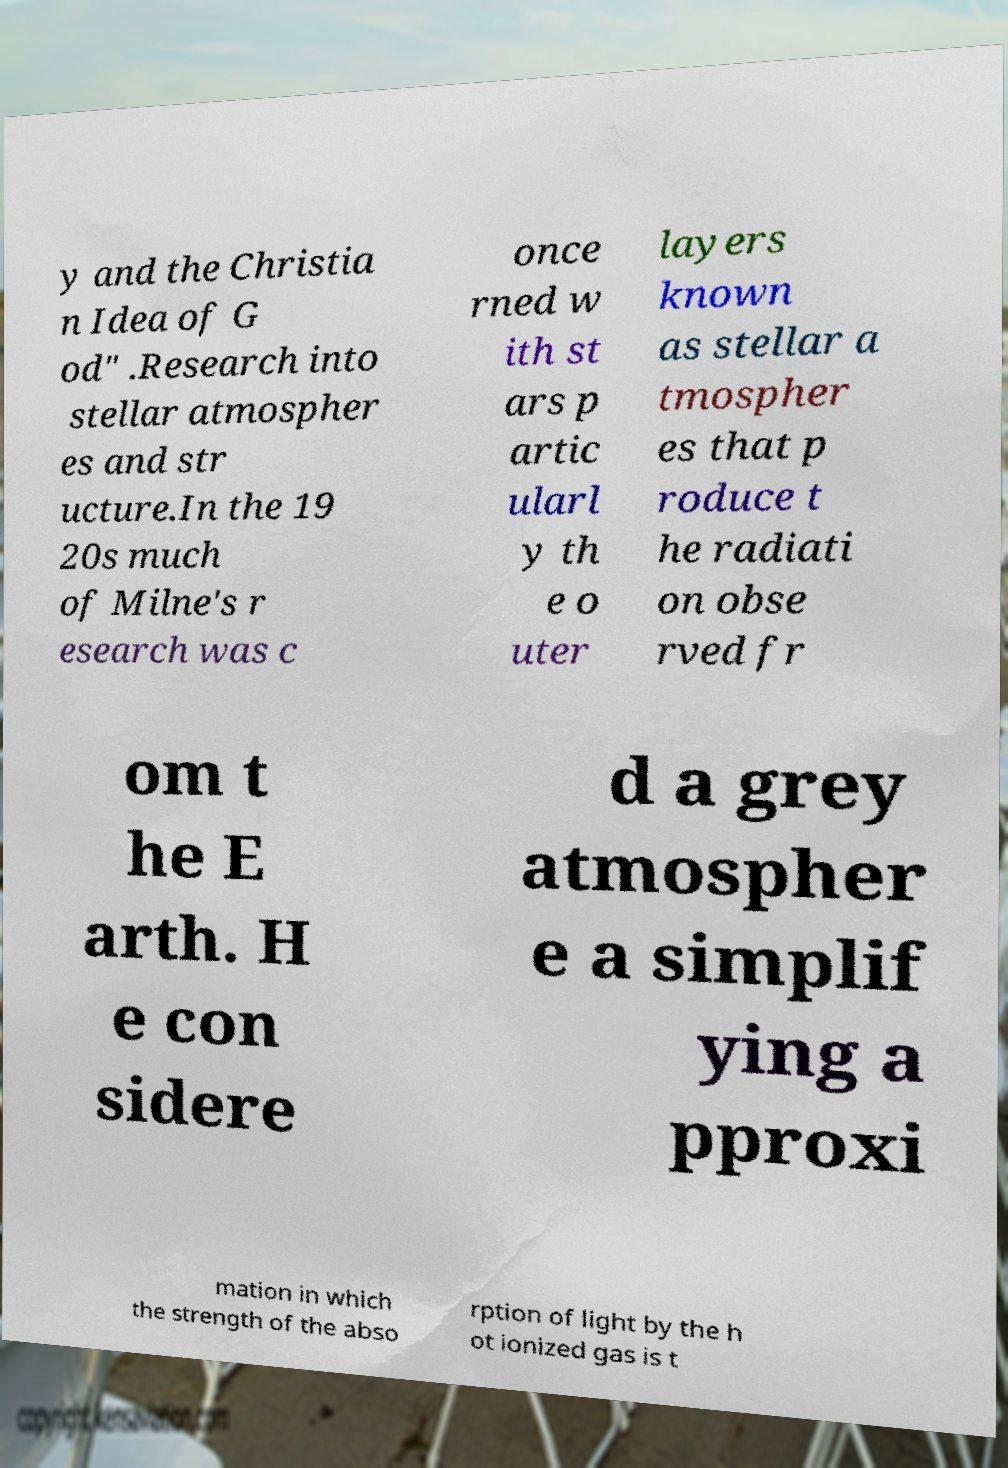Please identify and transcribe the text found in this image. y and the Christia n Idea of G od" .Research into stellar atmospher es and str ucture.In the 19 20s much of Milne's r esearch was c once rned w ith st ars p artic ularl y th e o uter layers known as stellar a tmospher es that p roduce t he radiati on obse rved fr om t he E arth. H e con sidere d a grey atmospher e a simplif ying a pproxi mation in which the strength of the abso rption of light by the h ot ionized gas is t 